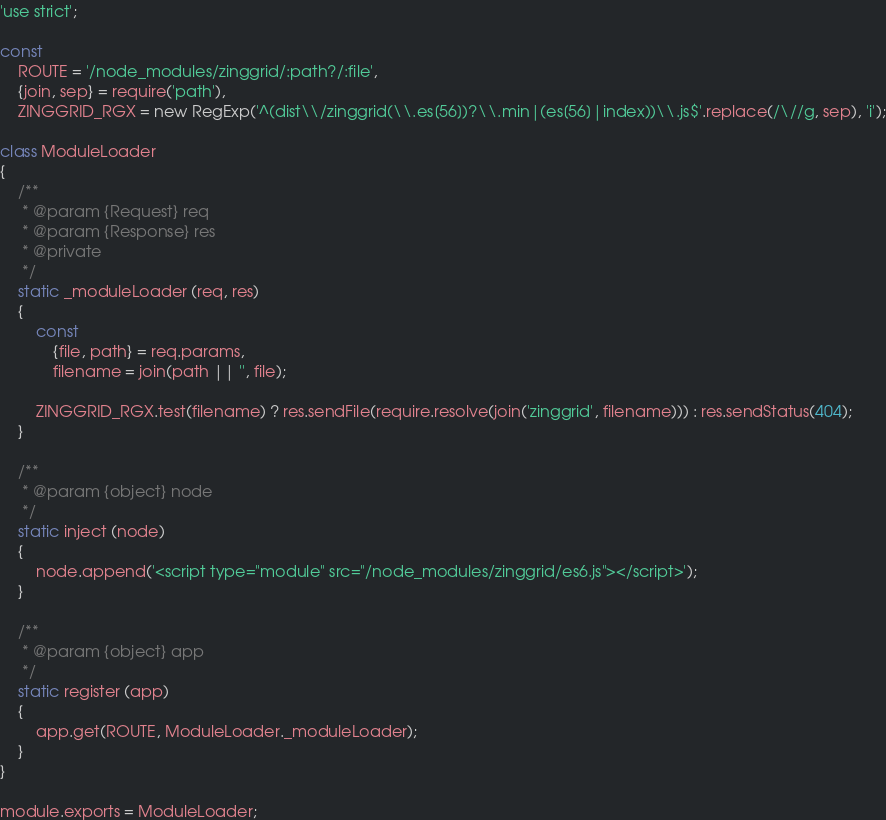<code> <loc_0><loc_0><loc_500><loc_500><_JavaScript_>'use strict';

const
    ROUTE = '/node_modules/zinggrid/:path?/:file',
    {join, sep} = require('path'),
    ZINGGRID_RGX = new RegExp('^(dist\\/zinggrid(\\.es[56])?\\.min|(es[56]|index))\\.js$'.replace(/\//g, sep), 'i');

class ModuleLoader
{
    /**
     * @param {Request} req
     * @param {Response} res
     * @private
     */
    static _moduleLoader (req, res)
    {
        const
            {file, path} = req.params,
            filename = join(path || '', file);

        ZINGGRID_RGX.test(filename) ? res.sendFile(require.resolve(join('zinggrid', filename))) : res.sendStatus(404);
    }

    /**
     * @param {object} node
     */
    static inject (node)
    {
        node.append('<script type="module" src="/node_modules/zinggrid/es6.js"></script>');
    }

    /**
     * @param {object} app
     */
    static register (app)
    {
        app.get(ROUTE, ModuleLoader._moduleLoader);
    }
}

module.exports = ModuleLoader;</code> 